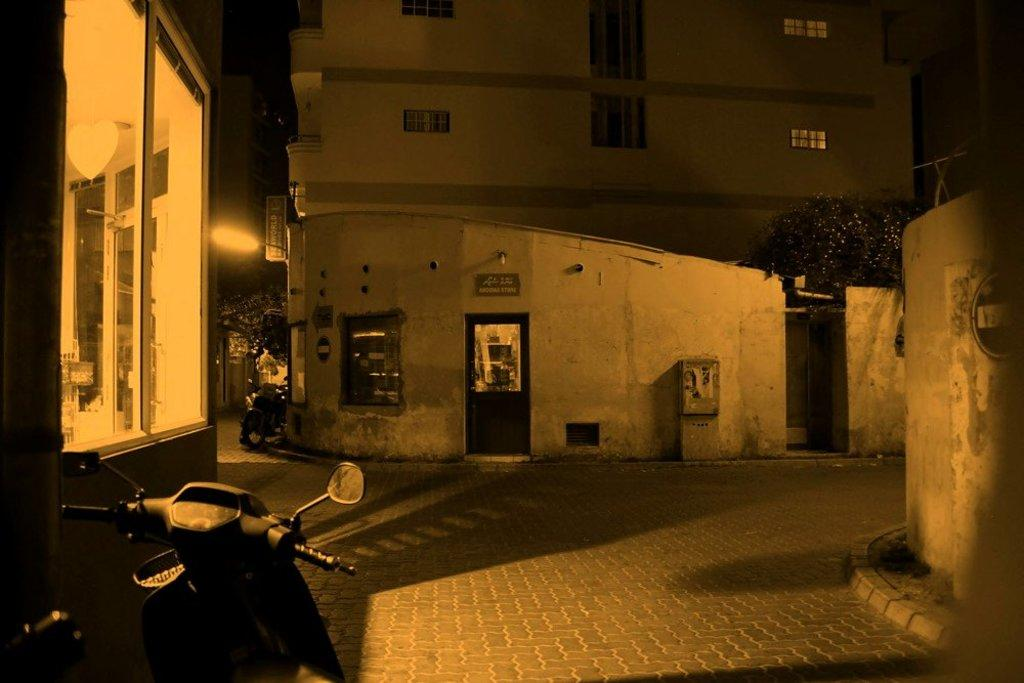What is the main subject of the image? The main subject of the image is a motorcycle. What else can be seen in the image besides the motorcycle? There are buildings and trees in the image. What type of guitar is being played by the visitor in the image? There is no guitar or visitor present in the image. 